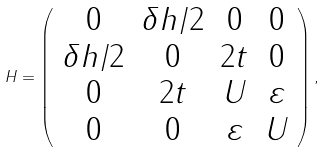Convert formula to latex. <formula><loc_0><loc_0><loc_500><loc_500>H = \left ( \begin{array} { c c c c } 0 & \delta h / 2 & 0 & 0 \\ \delta h / 2 & 0 & 2 t & 0 \\ 0 & 2 t & U & \varepsilon \\ 0 & 0 & \varepsilon & U \end{array} \right ) ,</formula> 